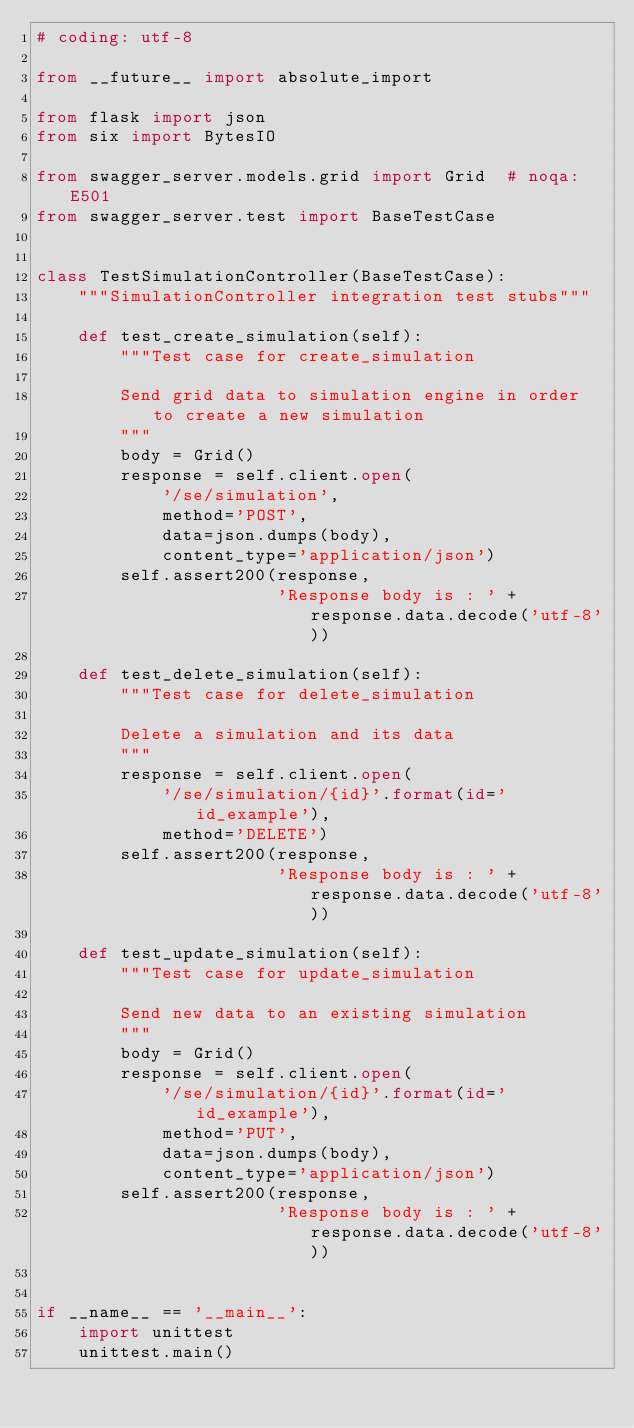Convert code to text. <code><loc_0><loc_0><loc_500><loc_500><_Python_># coding: utf-8

from __future__ import absolute_import

from flask import json
from six import BytesIO

from swagger_server.models.grid import Grid  # noqa: E501
from swagger_server.test import BaseTestCase


class TestSimulationController(BaseTestCase):
    """SimulationController integration test stubs"""

    def test_create_simulation(self):
        """Test case for create_simulation

        Send grid data to simulation engine in order to create a new simulation
        """
        body = Grid()
        response = self.client.open(
            '/se/simulation',
            method='POST',
            data=json.dumps(body),
            content_type='application/json')
        self.assert200(response,
                       'Response body is : ' + response.data.decode('utf-8'))

    def test_delete_simulation(self):
        """Test case for delete_simulation

        Delete a simulation and its data
        """
        response = self.client.open(
            '/se/simulation/{id}'.format(id='id_example'),
            method='DELETE')
        self.assert200(response,
                       'Response body is : ' + response.data.decode('utf-8'))

    def test_update_simulation(self):
        """Test case for update_simulation

        Send new data to an existing simulation
        """
        body = Grid()
        response = self.client.open(
            '/se/simulation/{id}'.format(id='id_example'),
            method='PUT',
            data=json.dumps(body),
            content_type='application/json')
        self.assert200(response,
                       'Response body is : ' + response.data.decode('utf-8'))


if __name__ == '__main__':
    import unittest
    unittest.main()
</code> 